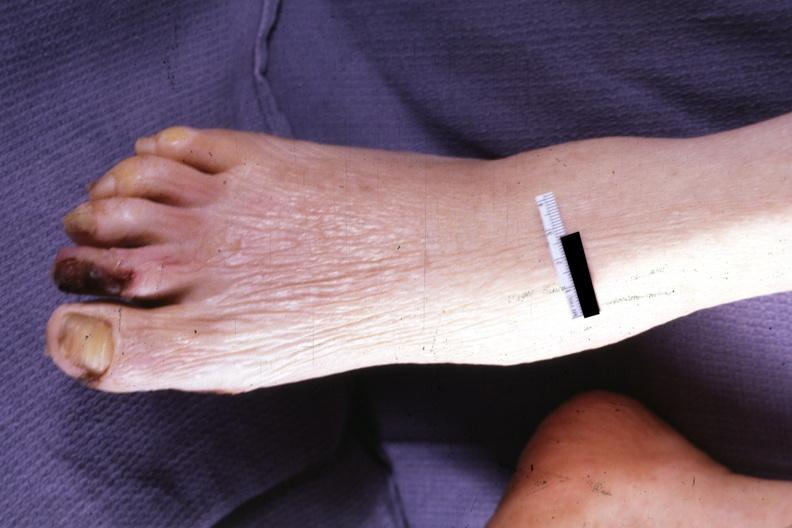does leiomyosarcoma show typical small lesion?
Answer the question using a single word or phrase. No 